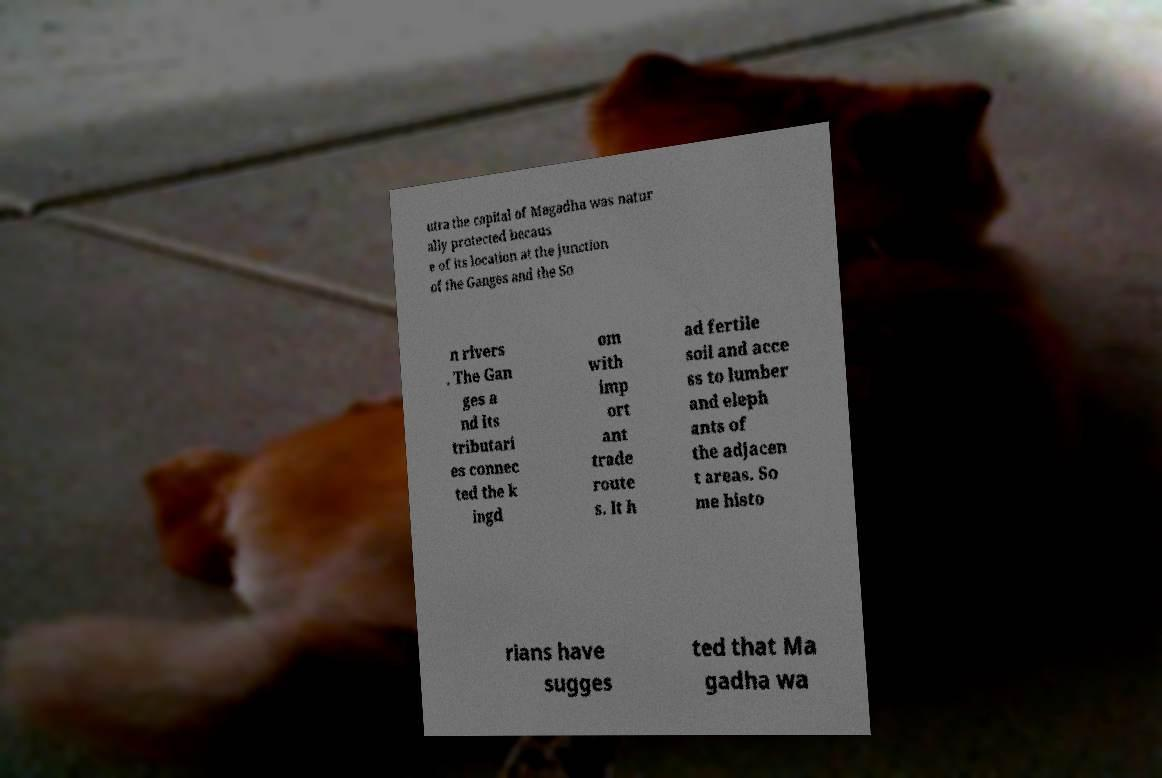What messages or text are displayed in this image? I need them in a readable, typed format. utra the capital of Magadha was natur ally protected becaus e of its location at the junction of the Ganges and the So n rivers . The Gan ges a nd its tributari es connec ted the k ingd om with imp ort ant trade route s. It h ad fertile soil and acce ss to lumber and eleph ants of the adjacen t areas. So me histo rians have sugges ted that Ma gadha wa 